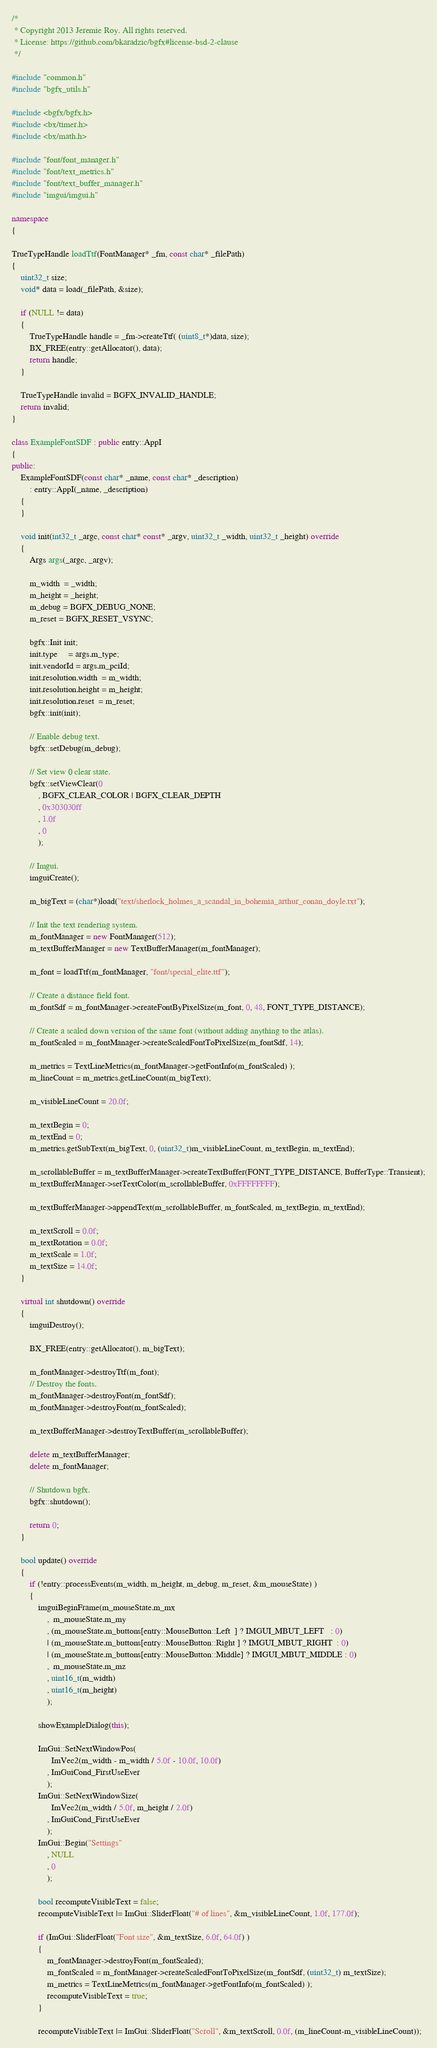Convert code to text. <code><loc_0><loc_0><loc_500><loc_500><_C++_>/*
 * Copyright 2013 Jeremie Roy. All rights reserved.
 * License: https://github.com/bkaradzic/bgfx#license-bsd-2-clause
 */

#include "common.h"
#include "bgfx_utils.h"

#include <bgfx/bgfx.h>
#include <bx/timer.h>
#include <bx/math.h>

#include "font/font_manager.h"
#include "font/text_metrics.h"
#include "font/text_buffer_manager.h"
#include "imgui/imgui.h"

namespace
{

TrueTypeHandle loadTtf(FontManager* _fm, const char* _filePath)
{
	uint32_t size;
	void* data = load(_filePath, &size);

	if (NULL != data)
	{
		TrueTypeHandle handle = _fm->createTtf( (uint8_t*)data, size);
		BX_FREE(entry::getAllocator(), data);
		return handle;
	}

	TrueTypeHandle invalid = BGFX_INVALID_HANDLE;
	return invalid;
}

class ExampleFontSDF : public entry::AppI
{
public:
	ExampleFontSDF(const char* _name, const char* _description)
		: entry::AppI(_name, _description)
	{
	}

	void init(int32_t _argc, const char* const* _argv, uint32_t _width, uint32_t _height) override
	{
		Args args(_argc, _argv);

		m_width  = _width;
		m_height = _height;
		m_debug = BGFX_DEBUG_NONE;
		m_reset = BGFX_RESET_VSYNC;

		bgfx::Init init;
		init.type     = args.m_type;
		init.vendorId = args.m_pciId;
		init.resolution.width  = m_width;
		init.resolution.height = m_height;
		init.resolution.reset  = m_reset;
		bgfx::init(init);

		// Enable debug text.
		bgfx::setDebug(m_debug);

		// Set view 0 clear state.
		bgfx::setViewClear(0
			, BGFX_CLEAR_COLOR | BGFX_CLEAR_DEPTH
			, 0x303030ff
			, 1.0f
			, 0
			);

		// Imgui.
		imguiCreate();

		m_bigText = (char*)load("text/sherlock_holmes_a_scandal_in_bohemia_arthur_conan_doyle.txt");

		// Init the text rendering system.
		m_fontManager = new FontManager(512);
		m_textBufferManager = new TextBufferManager(m_fontManager);

		m_font = loadTtf(m_fontManager, "font/special_elite.ttf");

		// Create a distance field font.
		m_fontSdf = m_fontManager->createFontByPixelSize(m_font, 0, 48, FONT_TYPE_DISTANCE);

		// Create a scaled down version of the same font (without adding anything to the atlas).
		m_fontScaled = m_fontManager->createScaledFontToPixelSize(m_fontSdf, 14);

		m_metrics = TextLineMetrics(m_fontManager->getFontInfo(m_fontScaled) );
		m_lineCount = m_metrics.getLineCount(m_bigText);

		m_visibleLineCount = 20.0f;

		m_textBegin = 0;
		m_textEnd = 0;
		m_metrics.getSubText(m_bigText, 0, (uint32_t)m_visibleLineCount, m_textBegin, m_textEnd);

		m_scrollableBuffer = m_textBufferManager->createTextBuffer(FONT_TYPE_DISTANCE, BufferType::Transient);
		m_textBufferManager->setTextColor(m_scrollableBuffer, 0xFFFFFFFF);

		m_textBufferManager->appendText(m_scrollableBuffer, m_fontScaled, m_textBegin, m_textEnd);

		m_textScroll = 0.0f;
		m_textRotation = 0.0f;
		m_textScale = 1.0f;
		m_textSize = 14.0f;
	}

	virtual int shutdown() override
	{
		imguiDestroy();

		BX_FREE(entry::getAllocator(), m_bigText);

		m_fontManager->destroyTtf(m_font);
		// Destroy the fonts.
		m_fontManager->destroyFont(m_fontSdf);
		m_fontManager->destroyFont(m_fontScaled);

		m_textBufferManager->destroyTextBuffer(m_scrollableBuffer);

		delete m_textBufferManager;
		delete m_fontManager;

		// Shutdown bgfx.
		bgfx::shutdown();

		return 0;
	}

	bool update() override
	{
		if (!entry::processEvents(m_width, m_height, m_debug, m_reset, &m_mouseState) )
		{
			imguiBeginFrame(m_mouseState.m_mx
				,  m_mouseState.m_my
				, (m_mouseState.m_buttons[entry::MouseButton::Left  ] ? IMGUI_MBUT_LEFT   : 0)
				| (m_mouseState.m_buttons[entry::MouseButton::Right ] ? IMGUI_MBUT_RIGHT  : 0)
				| (m_mouseState.m_buttons[entry::MouseButton::Middle] ? IMGUI_MBUT_MIDDLE : 0)
				,  m_mouseState.m_mz
				, uint16_t(m_width)
				, uint16_t(m_height)
				);

			showExampleDialog(this);

			ImGui::SetNextWindowPos(
				  ImVec2(m_width - m_width / 5.0f - 10.0f, 10.0f)
				, ImGuiCond_FirstUseEver
				);
			ImGui::SetNextWindowSize(
				  ImVec2(m_width / 5.0f, m_height / 2.0f)
				, ImGuiCond_FirstUseEver
				);
			ImGui::Begin("Settings"
				, NULL
				, 0
				);

			bool recomputeVisibleText = false;
			recomputeVisibleText |= ImGui::SliderFloat("# of lines", &m_visibleLineCount, 1.0f, 177.0f);

			if (ImGui::SliderFloat("Font size", &m_textSize, 6.0f, 64.0f) )
			{
				m_fontManager->destroyFont(m_fontScaled);
				m_fontScaled = m_fontManager->createScaledFontToPixelSize(m_fontSdf, (uint32_t) m_textSize);
				m_metrics = TextLineMetrics(m_fontManager->getFontInfo(m_fontScaled) );
				recomputeVisibleText = true;
			}

			recomputeVisibleText |= ImGui::SliderFloat("Scroll", &m_textScroll, 0.0f, (m_lineCount-m_visibleLineCount));</code> 